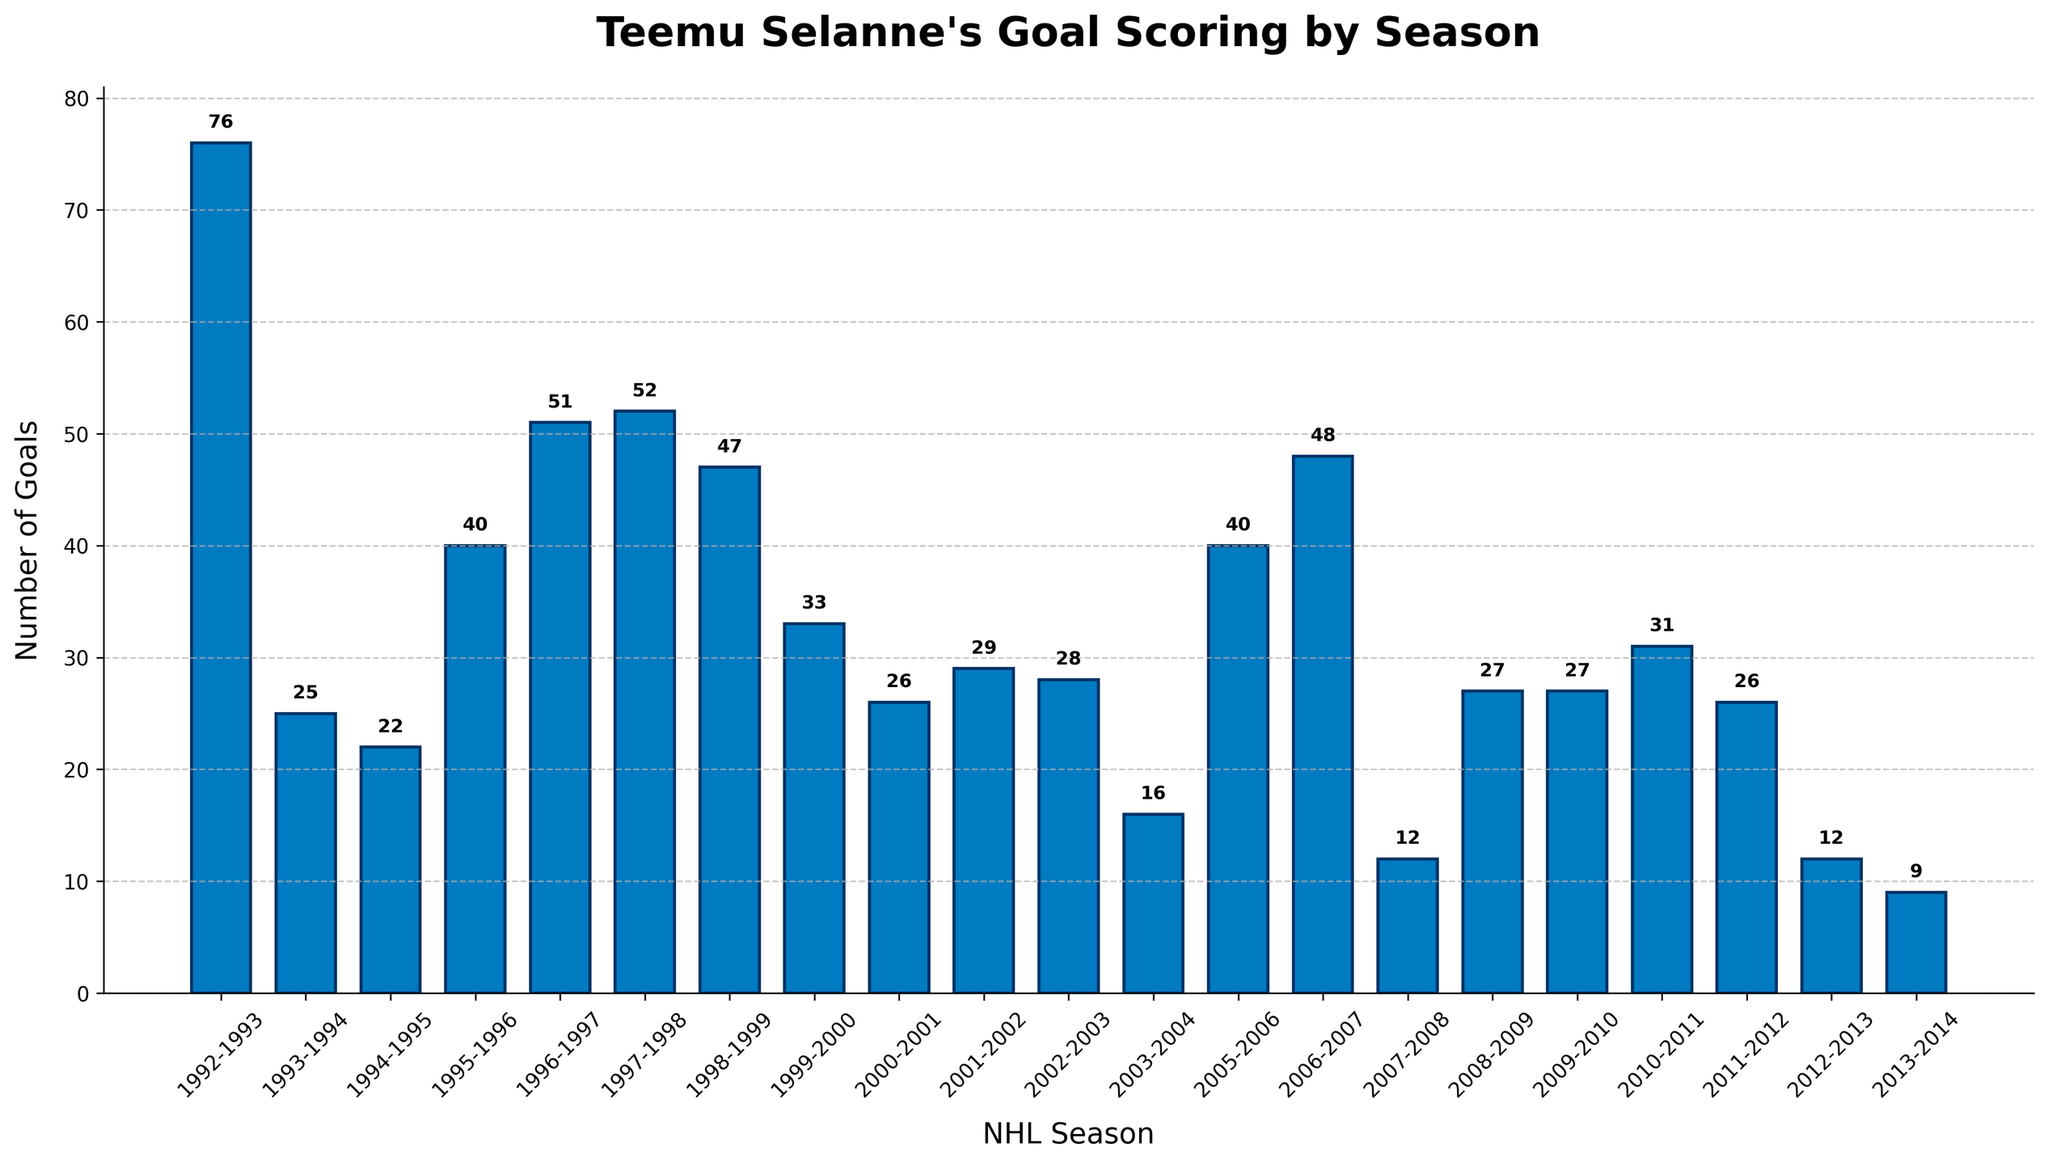what is the total number of goals Teemu Selanne scored in his career according to the figure? Sum up all the goals from each season. The total is 76 + 25 + 22 + 40 + 51 + 52 + 47 + 33 + 26 + 29 + 28 + 16 + 40 + 48 + 12 + 27 + 27 + 31 + 26 + 12 + 9 = 651
Answer: 651 Which season did Teemu Selanne score the most goals? Look for the highest bar in the chart and find the corresponding season. The highest bar corresponds to the 1992-1993 season with 76 goals
Answer: 1992-1993 How many goals did Teemu Selanne score in the 2005-2006 season compared to the 1994-1995 season? Identify the bars for the 2005-2006 season (40 goals) and the 1994-1995 season (22 goals), then find the difference: 40 - 22 = 18
Answer: 18 more goals What is the average number of goals per season Teemu Selanne scored in his career? Total the goals and divide by the number of seasons. Total goals = 651, number of seasons = 21, so the average is 651 / 21 ≈ 31 goals per season
Answer: 31 Which season did Teemu Selanne score the least number of goals? Identify the shortest bar in the chart and find the corresponding season. The shortest bar corresponds to the 2013-2014 season with 9 goals
Answer: 2013-2014 In how many seasons did Teemu Selanne score more than 50 goals? Count the bars that exceed the 50-goal mark. There are 3 such seasons (1992-1993, 1996-1997, 1997-1998)
Answer: 3 What is the difference in the number of goals between Teemu Selanne's highest scoring season and his lowest scoring season? The highest scoring season (1992-1993) had 76 goals and the lowest scoring season (2013-2014) had 9 goals. Difference: 76 - 9 = 67
Answer: 67 Over which consecutive seasons did Teemu Selanne score exactly 27 goals each season? Look for seasons where the bars indicate exactly 27 goals. This pattern appears in the 2008-2009 and 2009-2010 seasons
Answer: 2008-2009 and 2009-2010 What is the median number of goals scored across all seasons? Arrange the goals in ascending order and find the middle number. Arranged goals: 9, 12, 12, 16, 22, 25, 26, 26, 27, 27, 28, 29, 31, 33, 40, 40, 47, 48, 51, 52, 76. The median value is the 11th number: 28
Answer: 28 